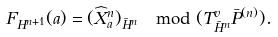<formula> <loc_0><loc_0><loc_500><loc_500>F _ { H ^ { n + 1 } } ( a ) = ( \widehat { X } ^ { n } _ { a } ) _ { \bar { H } ^ { n } } \mod ( T ^ { v } _ { \bar { H } ^ { n } } \bar { P } ^ { ( n ) } ) .</formula> 